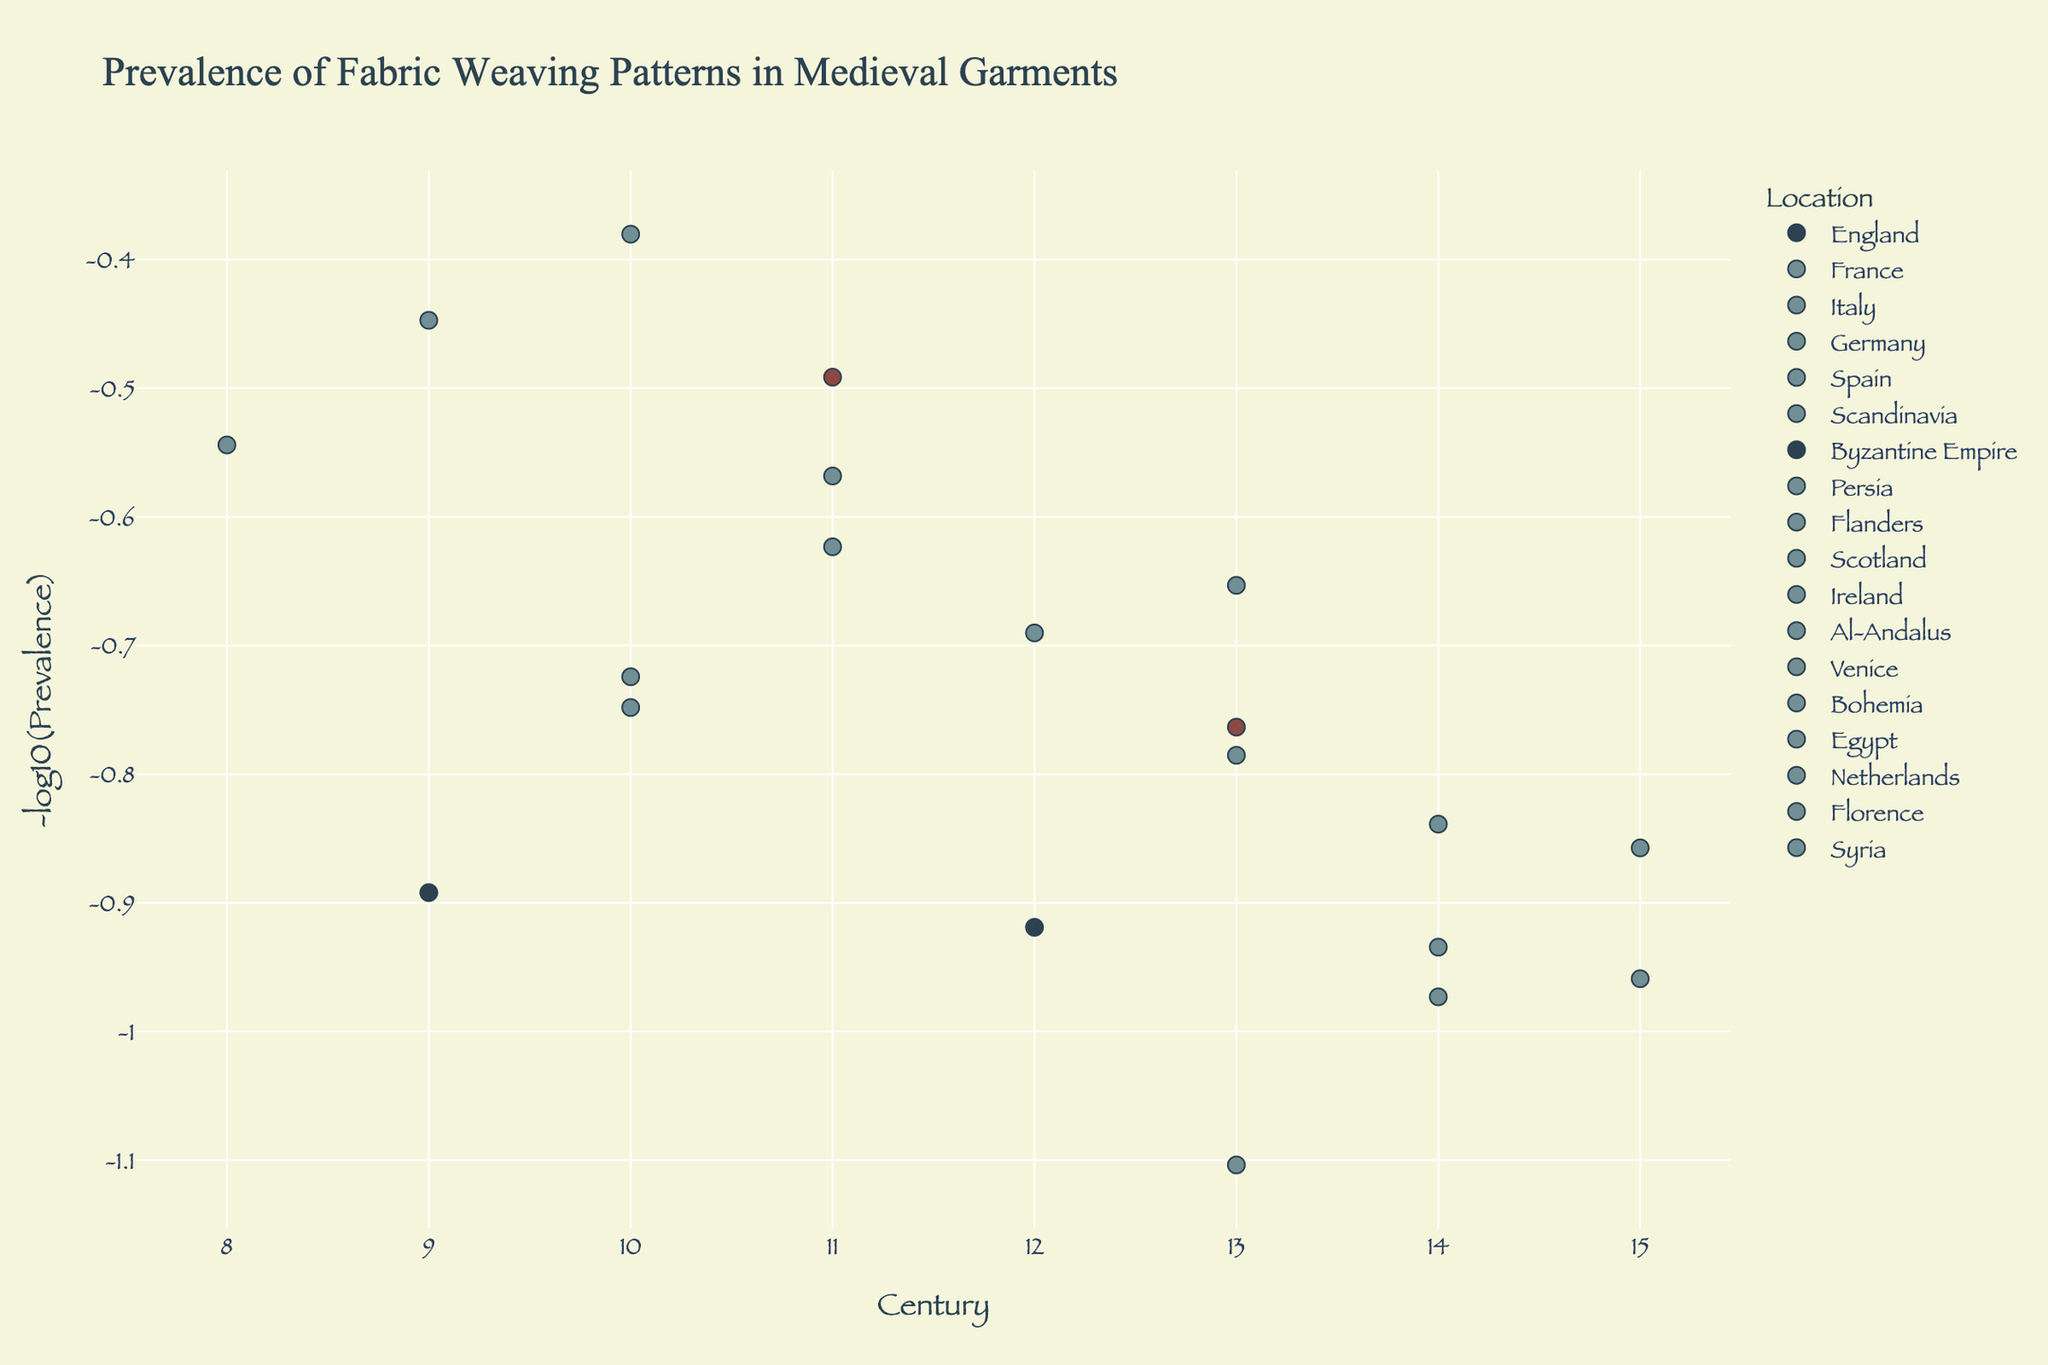What is the title of the plot? The title of the plot is displayed at the top center in large font. It reads “Prevalence of Fabric Weaving Patterns in Medieval Garments.”
Answer: Prevalence of Fabric Weaving Patterns in Medieval Garments What is the y-axis title? The y-axis title is displayed along the y-axis and it reads “-log10(Prevalence),” indicating that the y-values represent the negative logarithm of the prevalence values.
Answer: -log10(Prevalence) How many unique geographical locations are represented in the plot? The unique geographical locations are represented as different plot traces, each labeled in the legend. By counting them, we find there are 19 unique locations.
Answer: 19 In which century is the highest prevalence of any fabric weaving pattern observed? By looking at the scatter plot points and hover data, the highest y-value (smallest -log10(prevalence)) indicates the highest prevalence. This occurs for France in the 13th century with a prevalence of 12.7.
Answer: 13th century Which fabric has the lowest prevalence and in which location and century is it found? By identifying the highest y-value (since -log10(Prevalence) is inversely proportional to Prevalence), we see that Gauze in Syria during the 10th century has the lowest prevalence of 2.4.
Answer: Gauze in Syria in the 10th century What is the average -log10(Prevalence) of fabrics from the 14th century? Sum the -log10(Prevalence) values for all fabrics in the 14th century and then divide by the total number of these fabrics: (-log10(6.9) + -log10(8.6) + -log10(9.4))/3 ~ (1.16+1.07+1.03)/3 = 1.0867.
Answer: 1.09 Compare the prevalence of Twill in France in the 13th century to that of Canvas in the Netherlands in the 15th century. Which is higher? Look at the prevalence values from the hover data: Twill in France (13th century) has a prevalence of 12.7, Canvas in the Netherlands (15th century) has a prevalence of 7.2. Twill has a higher prevalence.
Answer: Twill Is there a clear trend in the prevalence of fabric weaving patterns over time? Examine the scatter points across centuries for patterns; most of the points do not form a clear upward or downward trend, indicating no obvious prevalence trend over time.
Answer: No Which location has the widest range of prevalence values and what is that range? Identify the location with the maximum difference between the highest and lowest prevalence values by checking the scatter points. For England, the difference is between 8.3 in 12th century and 5.8 in 13th century: 8.3 - 5.8 = 2.5.
Answer: England, range is 2.5 What century has the highest number of fabric patterns documented? Check each century for the number of scatter points associated with it. The 13th century has the most points.
Answer: 13th century 